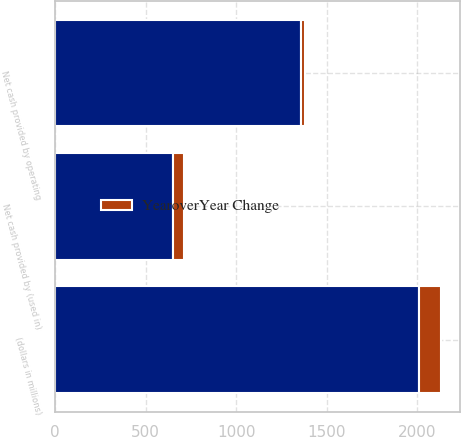Convert chart to OTSL. <chart><loc_0><loc_0><loc_500><loc_500><stacked_bar_chart><ecel><fcel>(dollars in millions)<fcel>Net cash provided by operating<fcel>Net cash provided by (used in)<nl><fcel>nan<fcel>2010<fcel>1356.4<fcel>653.4<nl><fcel>YearoverYear Change<fcel>120<fcel>25<fcel>61<nl></chart> 